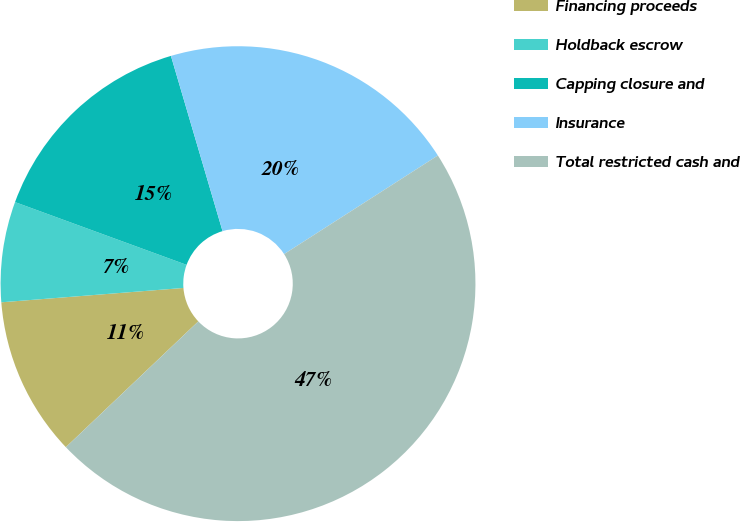Convert chart. <chart><loc_0><loc_0><loc_500><loc_500><pie_chart><fcel>Financing proceeds<fcel>Holdback escrow<fcel>Capping closure and<fcel>Insurance<fcel>Total restricted cash and<nl><fcel>10.84%<fcel>6.83%<fcel>14.86%<fcel>20.48%<fcel>46.98%<nl></chart> 